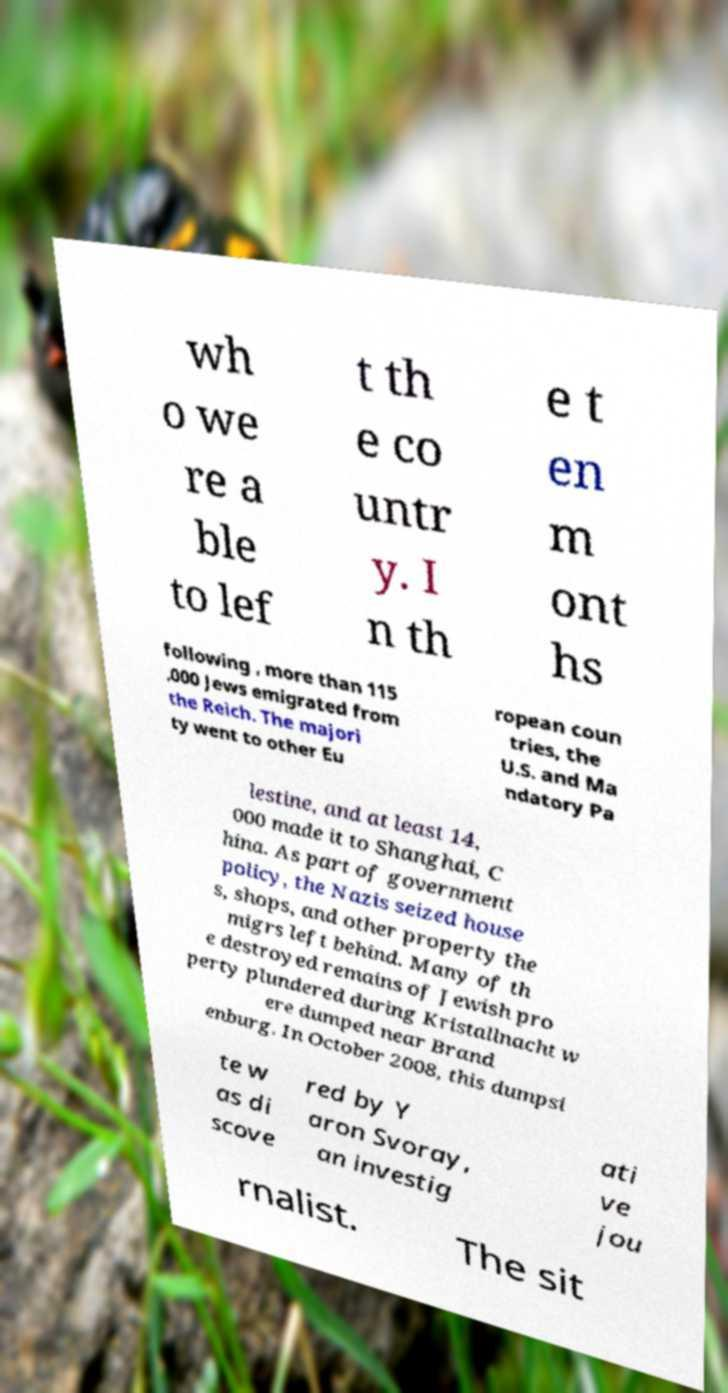Can you accurately transcribe the text from the provided image for me? wh o we re a ble to lef t th e co untr y. I n th e t en m ont hs following , more than 115 ,000 Jews emigrated from the Reich. The majori ty went to other Eu ropean coun tries, the U.S. and Ma ndatory Pa lestine, and at least 14, 000 made it to Shanghai, C hina. As part of government policy, the Nazis seized house s, shops, and other property the migrs left behind. Many of th e destroyed remains of Jewish pro perty plundered during Kristallnacht w ere dumped near Brand enburg. In October 2008, this dumpsi te w as di scove red by Y aron Svoray, an investig ati ve jou rnalist. The sit 